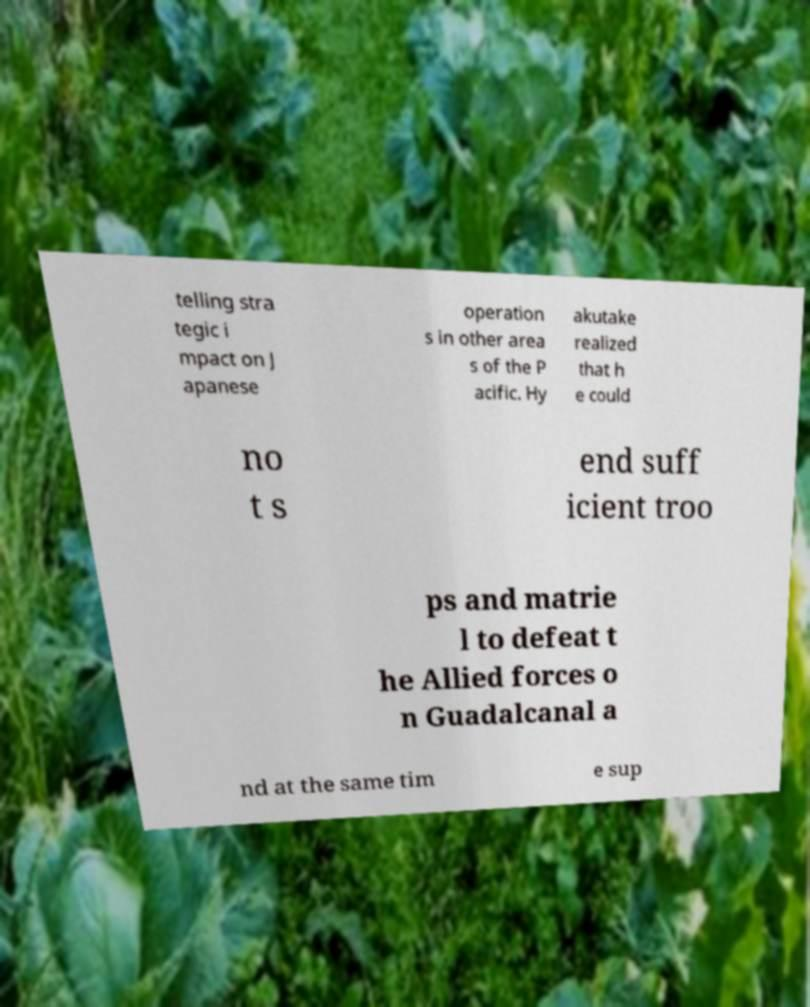What messages or text are displayed in this image? I need them in a readable, typed format. telling stra tegic i mpact on J apanese operation s in other area s of the P acific. Hy akutake realized that h e could no t s end suff icient troo ps and matrie l to defeat t he Allied forces o n Guadalcanal a nd at the same tim e sup 